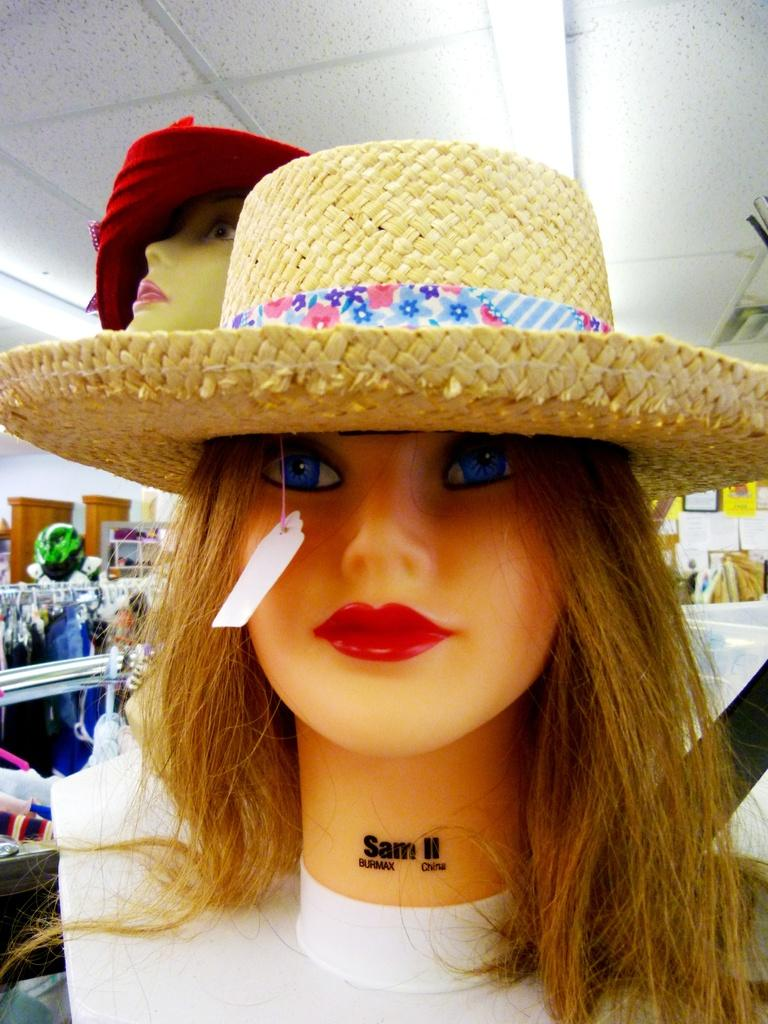What is located in the center of the image? There are mannequins in the center of the image. What type of accessories are visible in the image? There are hats in the image. What can be seen in the background of the image? There are clothes and a wall in the background. Where is the light source located in the image? The light is at the top of the image. What type of gold jewelry is the boy wearing in the image? There is no boy present in the image, and therefore no jewelry can be observed. 